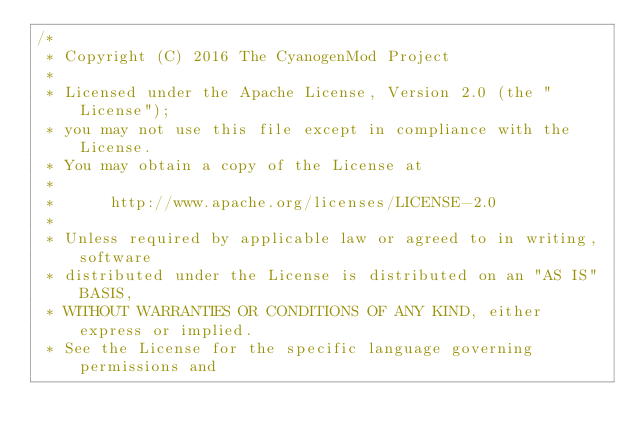Convert code to text. <code><loc_0><loc_0><loc_500><loc_500><_C_>/*
 * Copyright (C) 2016 The CyanogenMod Project
 *
 * Licensed under the Apache License, Version 2.0 (the "License");
 * you may not use this file except in compliance with the License.
 * You may obtain a copy of the License at
 *
 *      http://www.apache.org/licenses/LICENSE-2.0
 *
 * Unless required by applicable law or agreed to in writing, software
 * distributed under the License is distributed on an "AS IS" BASIS,
 * WITHOUT WARRANTIES OR CONDITIONS OF ANY KIND, either express or implied.
 * See the License for the specific language governing permissions and</code> 